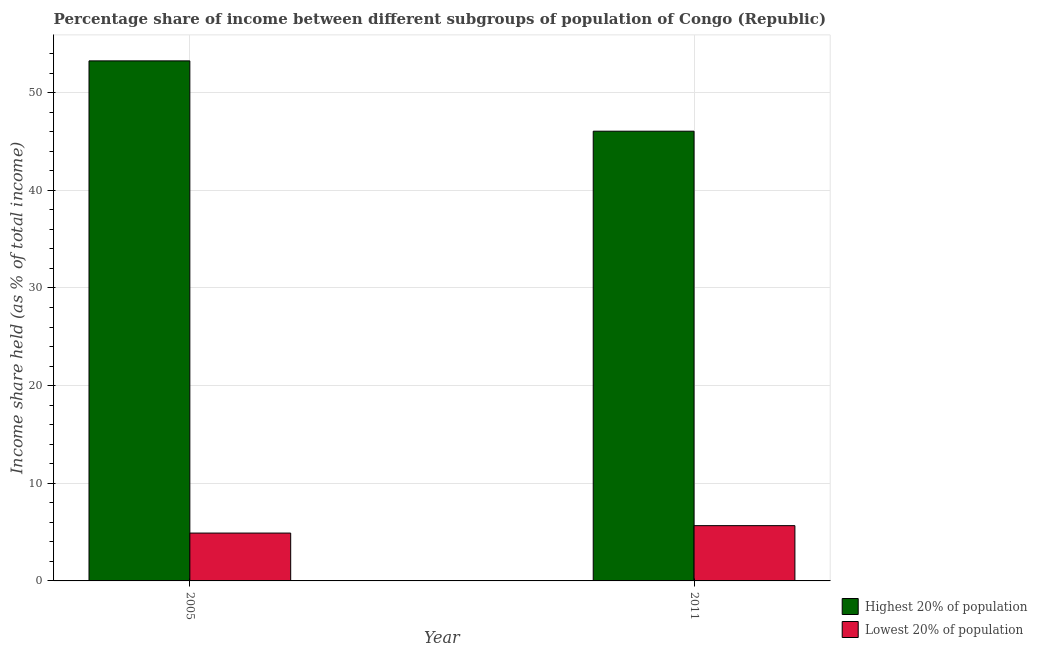How many different coloured bars are there?
Provide a succinct answer. 2. Are the number of bars per tick equal to the number of legend labels?
Give a very brief answer. Yes. Are the number of bars on each tick of the X-axis equal?
Your answer should be compact. Yes. How many bars are there on the 1st tick from the left?
Provide a succinct answer. 2. In how many cases, is the number of bars for a given year not equal to the number of legend labels?
Provide a succinct answer. 0. What is the income share held by highest 20% of the population in 2005?
Your answer should be very brief. 53.25. Across all years, what is the maximum income share held by highest 20% of the population?
Provide a short and direct response. 53.25. Across all years, what is the minimum income share held by highest 20% of the population?
Make the answer very short. 46.05. In which year was the income share held by highest 20% of the population maximum?
Offer a very short reply. 2005. In which year was the income share held by highest 20% of the population minimum?
Give a very brief answer. 2011. What is the total income share held by lowest 20% of the population in the graph?
Offer a terse response. 10.56. What is the difference between the income share held by lowest 20% of the population in 2005 and that in 2011?
Keep it short and to the point. -0.76. What is the difference between the income share held by highest 20% of the population in 2011 and the income share held by lowest 20% of the population in 2005?
Your answer should be very brief. -7.2. What is the average income share held by lowest 20% of the population per year?
Ensure brevity in your answer.  5.28. In how many years, is the income share held by highest 20% of the population greater than 22 %?
Keep it short and to the point. 2. What is the ratio of the income share held by highest 20% of the population in 2005 to that in 2011?
Keep it short and to the point. 1.16. Is the income share held by lowest 20% of the population in 2005 less than that in 2011?
Offer a terse response. Yes. In how many years, is the income share held by highest 20% of the population greater than the average income share held by highest 20% of the population taken over all years?
Make the answer very short. 1. What does the 1st bar from the left in 2011 represents?
Your answer should be very brief. Highest 20% of population. What does the 1st bar from the right in 2011 represents?
Provide a succinct answer. Lowest 20% of population. How many bars are there?
Your response must be concise. 4. Does the graph contain any zero values?
Your response must be concise. No. Where does the legend appear in the graph?
Keep it short and to the point. Bottom right. How are the legend labels stacked?
Your answer should be very brief. Vertical. What is the title of the graph?
Make the answer very short. Percentage share of income between different subgroups of population of Congo (Republic). Does "From Government" appear as one of the legend labels in the graph?
Your response must be concise. No. What is the label or title of the X-axis?
Keep it short and to the point. Year. What is the label or title of the Y-axis?
Make the answer very short. Income share held (as % of total income). What is the Income share held (as % of total income) in Highest 20% of population in 2005?
Your answer should be compact. 53.25. What is the Income share held (as % of total income) of Highest 20% of population in 2011?
Keep it short and to the point. 46.05. What is the Income share held (as % of total income) of Lowest 20% of population in 2011?
Ensure brevity in your answer.  5.66. Across all years, what is the maximum Income share held (as % of total income) of Highest 20% of population?
Ensure brevity in your answer.  53.25. Across all years, what is the maximum Income share held (as % of total income) of Lowest 20% of population?
Your response must be concise. 5.66. Across all years, what is the minimum Income share held (as % of total income) in Highest 20% of population?
Make the answer very short. 46.05. What is the total Income share held (as % of total income) in Highest 20% of population in the graph?
Ensure brevity in your answer.  99.3. What is the total Income share held (as % of total income) of Lowest 20% of population in the graph?
Provide a short and direct response. 10.56. What is the difference between the Income share held (as % of total income) in Highest 20% of population in 2005 and that in 2011?
Provide a succinct answer. 7.2. What is the difference between the Income share held (as % of total income) of Lowest 20% of population in 2005 and that in 2011?
Your answer should be very brief. -0.76. What is the difference between the Income share held (as % of total income) in Highest 20% of population in 2005 and the Income share held (as % of total income) in Lowest 20% of population in 2011?
Keep it short and to the point. 47.59. What is the average Income share held (as % of total income) of Highest 20% of population per year?
Offer a terse response. 49.65. What is the average Income share held (as % of total income) of Lowest 20% of population per year?
Make the answer very short. 5.28. In the year 2005, what is the difference between the Income share held (as % of total income) in Highest 20% of population and Income share held (as % of total income) in Lowest 20% of population?
Provide a succinct answer. 48.35. In the year 2011, what is the difference between the Income share held (as % of total income) of Highest 20% of population and Income share held (as % of total income) of Lowest 20% of population?
Ensure brevity in your answer.  40.39. What is the ratio of the Income share held (as % of total income) of Highest 20% of population in 2005 to that in 2011?
Make the answer very short. 1.16. What is the ratio of the Income share held (as % of total income) of Lowest 20% of population in 2005 to that in 2011?
Ensure brevity in your answer.  0.87. What is the difference between the highest and the second highest Income share held (as % of total income) of Highest 20% of population?
Offer a very short reply. 7.2. What is the difference between the highest and the second highest Income share held (as % of total income) of Lowest 20% of population?
Provide a short and direct response. 0.76. What is the difference between the highest and the lowest Income share held (as % of total income) of Lowest 20% of population?
Keep it short and to the point. 0.76. 